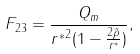<formula> <loc_0><loc_0><loc_500><loc_500>F _ { 2 3 } = \frac { Q _ { m } } { { r ^ { \ast } } ^ { 2 } ( 1 - \frac { 2 \tilde { \rho } } { r ^ { \ast } } ) } ,</formula> 